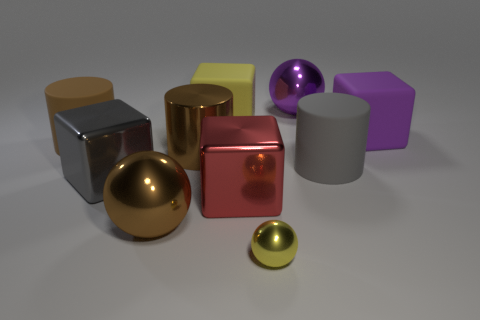Subtract all yellow cubes. How many cubes are left? 3 Subtract all yellow balls. How many brown cylinders are left? 2 Subtract all yellow spheres. How many spheres are left? 2 Subtract 1 yellow balls. How many objects are left? 9 Subtract all cubes. How many objects are left? 6 Subtract 1 cylinders. How many cylinders are left? 2 Subtract all green cubes. Subtract all blue balls. How many cubes are left? 4 Subtract all tiny brown matte things. Subtract all big brown things. How many objects are left? 7 Add 8 large red blocks. How many large red blocks are left? 9 Add 2 small green cylinders. How many small green cylinders exist? 2 